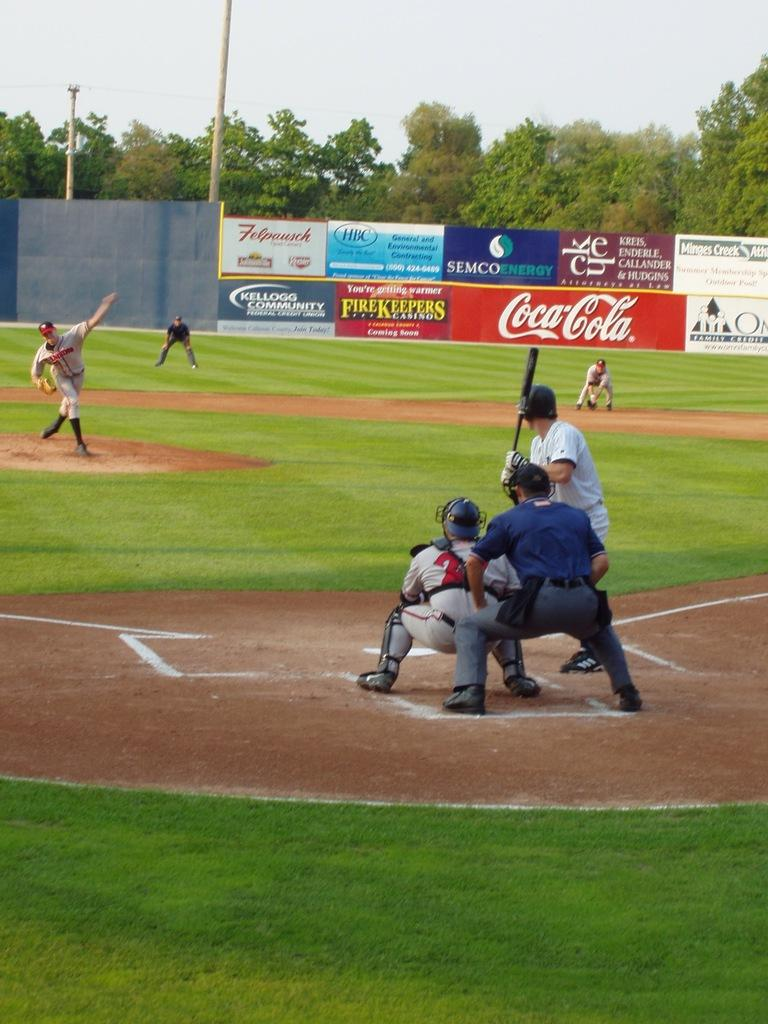<image>
Provide a brief description of the given image. A baseball game is underway at a stadium with a Coca-Cola sign. 